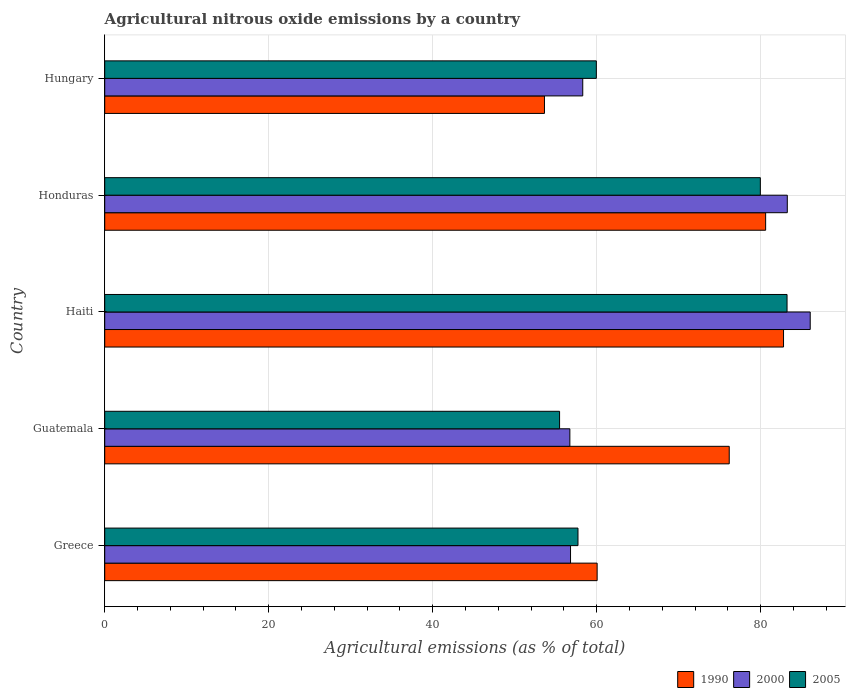How many groups of bars are there?
Provide a short and direct response. 5. Are the number of bars on each tick of the Y-axis equal?
Give a very brief answer. Yes. How many bars are there on the 2nd tick from the top?
Your answer should be very brief. 3. What is the label of the 2nd group of bars from the top?
Your answer should be compact. Honduras. What is the amount of agricultural nitrous oxide emitted in 1990 in Hungary?
Your answer should be very brief. 53.62. Across all countries, what is the maximum amount of agricultural nitrous oxide emitted in 1990?
Offer a terse response. 82.77. Across all countries, what is the minimum amount of agricultural nitrous oxide emitted in 2005?
Keep it short and to the point. 55.47. In which country was the amount of agricultural nitrous oxide emitted in 1990 maximum?
Your answer should be compact. Haiti. In which country was the amount of agricultural nitrous oxide emitted in 2005 minimum?
Provide a succinct answer. Guatemala. What is the total amount of agricultural nitrous oxide emitted in 2000 in the graph?
Give a very brief answer. 341.08. What is the difference between the amount of agricultural nitrous oxide emitted in 2005 in Guatemala and that in Hungary?
Ensure brevity in your answer.  -4.48. What is the difference between the amount of agricultural nitrous oxide emitted in 1990 in Greece and the amount of agricultural nitrous oxide emitted in 2005 in Hungary?
Offer a terse response. 0.1. What is the average amount of agricultural nitrous oxide emitted in 2000 per country?
Your answer should be compact. 68.22. What is the difference between the amount of agricultural nitrous oxide emitted in 2000 and amount of agricultural nitrous oxide emitted in 2005 in Honduras?
Keep it short and to the point. 3.29. What is the ratio of the amount of agricultural nitrous oxide emitted in 1990 in Haiti to that in Honduras?
Give a very brief answer. 1.03. What is the difference between the highest and the second highest amount of agricultural nitrous oxide emitted in 2005?
Make the answer very short. 3.26. What is the difference between the highest and the lowest amount of agricultural nitrous oxide emitted in 2000?
Offer a very short reply. 29.31. Is it the case that in every country, the sum of the amount of agricultural nitrous oxide emitted in 2000 and amount of agricultural nitrous oxide emitted in 2005 is greater than the amount of agricultural nitrous oxide emitted in 1990?
Offer a very short reply. Yes. Are all the bars in the graph horizontal?
Make the answer very short. Yes. What is the difference between two consecutive major ticks on the X-axis?
Keep it short and to the point. 20. What is the title of the graph?
Your answer should be very brief. Agricultural nitrous oxide emissions by a country. Does "2010" appear as one of the legend labels in the graph?
Offer a terse response. No. What is the label or title of the X-axis?
Your answer should be very brief. Agricultural emissions (as % of total). What is the label or title of the Y-axis?
Offer a terse response. Country. What is the Agricultural emissions (as % of total) of 1990 in Greece?
Your answer should be compact. 60.05. What is the Agricultural emissions (as % of total) in 2000 in Greece?
Offer a very short reply. 56.8. What is the Agricultural emissions (as % of total) in 2005 in Greece?
Your response must be concise. 57.71. What is the Agricultural emissions (as % of total) of 1990 in Guatemala?
Give a very brief answer. 76.15. What is the Agricultural emissions (as % of total) in 2000 in Guatemala?
Offer a very short reply. 56.72. What is the Agricultural emissions (as % of total) of 2005 in Guatemala?
Ensure brevity in your answer.  55.47. What is the Agricultural emissions (as % of total) in 1990 in Haiti?
Your answer should be compact. 82.77. What is the Agricultural emissions (as % of total) in 2000 in Haiti?
Your answer should be very brief. 86.03. What is the Agricultural emissions (as % of total) in 2005 in Haiti?
Offer a terse response. 83.2. What is the Agricultural emissions (as % of total) of 1990 in Honduras?
Give a very brief answer. 80.59. What is the Agricultural emissions (as % of total) of 2000 in Honduras?
Ensure brevity in your answer.  83.23. What is the Agricultural emissions (as % of total) in 2005 in Honduras?
Ensure brevity in your answer.  79.95. What is the Agricultural emissions (as % of total) of 1990 in Hungary?
Provide a short and direct response. 53.62. What is the Agricultural emissions (as % of total) of 2000 in Hungary?
Provide a short and direct response. 58.29. What is the Agricultural emissions (as % of total) of 2005 in Hungary?
Provide a short and direct response. 59.95. Across all countries, what is the maximum Agricultural emissions (as % of total) of 1990?
Provide a succinct answer. 82.77. Across all countries, what is the maximum Agricultural emissions (as % of total) in 2000?
Offer a terse response. 86.03. Across all countries, what is the maximum Agricultural emissions (as % of total) in 2005?
Provide a short and direct response. 83.2. Across all countries, what is the minimum Agricultural emissions (as % of total) in 1990?
Ensure brevity in your answer.  53.62. Across all countries, what is the minimum Agricultural emissions (as % of total) in 2000?
Ensure brevity in your answer.  56.72. Across all countries, what is the minimum Agricultural emissions (as % of total) of 2005?
Offer a terse response. 55.47. What is the total Agricultural emissions (as % of total) of 1990 in the graph?
Ensure brevity in your answer.  353.19. What is the total Agricultural emissions (as % of total) of 2000 in the graph?
Provide a short and direct response. 341.07. What is the total Agricultural emissions (as % of total) in 2005 in the graph?
Offer a terse response. 336.27. What is the difference between the Agricultural emissions (as % of total) of 1990 in Greece and that in Guatemala?
Your answer should be very brief. -16.11. What is the difference between the Agricultural emissions (as % of total) in 2000 in Greece and that in Guatemala?
Keep it short and to the point. 0.08. What is the difference between the Agricultural emissions (as % of total) in 2005 in Greece and that in Guatemala?
Keep it short and to the point. 2.24. What is the difference between the Agricultural emissions (as % of total) in 1990 in Greece and that in Haiti?
Provide a short and direct response. -22.73. What is the difference between the Agricultural emissions (as % of total) in 2000 in Greece and that in Haiti?
Your response must be concise. -29.23. What is the difference between the Agricultural emissions (as % of total) of 2005 in Greece and that in Haiti?
Your answer should be very brief. -25.49. What is the difference between the Agricultural emissions (as % of total) in 1990 in Greece and that in Honduras?
Your answer should be very brief. -20.55. What is the difference between the Agricultural emissions (as % of total) in 2000 in Greece and that in Honduras?
Your answer should be compact. -26.43. What is the difference between the Agricultural emissions (as % of total) of 2005 in Greece and that in Honduras?
Offer a very short reply. -22.24. What is the difference between the Agricultural emissions (as % of total) in 1990 in Greece and that in Hungary?
Your answer should be very brief. 6.42. What is the difference between the Agricultural emissions (as % of total) of 2000 in Greece and that in Hungary?
Offer a very short reply. -1.49. What is the difference between the Agricultural emissions (as % of total) in 2005 in Greece and that in Hungary?
Keep it short and to the point. -2.24. What is the difference between the Agricultural emissions (as % of total) of 1990 in Guatemala and that in Haiti?
Your answer should be compact. -6.62. What is the difference between the Agricultural emissions (as % of total) in 2000 in Guatemala and that in Haiti?
Offer a very short reply. -29.31. What is the difference between the Agricultural emissions (as % of total) of 2005 in Guatemala and that in Haiti?
Offer a terse response. -27.74. What is the difference between the Agricultural emissions (as % of total) of 1990 in Guatemala and that in Honduras?
Make the answer very short. -4.44. What is the difference between the Agricultural emissions (as % of total) of 2000 in Guatemala and that in Honduras?
Give a very brief answer. -26.52. What is the difference between the Agricultural emissions (as % of total) in 2005 in Guatemala and that in Honduras?
Make the answer very short. -24.48. What is the difference between the Agricultural emissions (as % of total) in 1990 in Guatemala and that in Hungary?
Your answer should be very brief. 22.53. What is the difference between the Agricultural emissions (as % of total) in 2000 in Guatemala and that in Hungary?
Ensure brevity in your answer.  -1.57. What is the difference between the Agricultural emissions (as % of total) of 2005 in Guatemala and that in Hungary?
Your answer should be very brief. -4.48. What is the difference between the Agricultural emissions (as % of total) of 1990 in Haiti and that in Honduras?
Your response must be concise. 2.18. What is the difference between the Agricultural emissions (as % of total) of 2000 in Haiti and that in Honduras?
Give a very brief answer. 2.79. What is the difference between the Agricultural emissions (as % of total) in 2005 in Haiti and that in Honduras?
Ensure brevity in your answer.  3.26. What is the difference between the Agricultural emissions (as % of total) of 1990 in Haiti and that in Hungary?
Ensure brevity in your answer.  29.15. What is the difference between the Agricultural emissions (as % of total) of 2000 in Haiti and that in Hungary?
Provide a succinct answer. 27.74. What is the difference between the Agricultural emissions (as % of total) of 2005 in Haiti and that in Hungary?
Your answer should be very brief. 23.25. What is the difference between the Agricultural emissions (as % of total) of 1990 in Honduras and that in Hungary?
Your response must be concise. 26.97. What is the difference between the Agricultural emissions (as % of total) of 2000 in Honduras and that in Hungary?
Provide a short and direct response. 24.94. What is the difference between the Agricultural emissions (as % of total) of 2005 in Honduras and that in Hungary?
Offer a very short reply. 20. What is the difference between the Agricultural emissions (as % of total) in 1990 in Greece and the Agricultural emissions (as % of total) in 2000 in Guatemala?
Your answer should be compact. 3.33. What is the difference between the Agricultural emissions (as % of total) in 1990 in Greece and the Agricultural emissions (as % of total) in 2005 in Guatemala?
Your answer should be very brief. 4.58. What is the difference between the Agricultural emissions (as % of total) in 2000 in Greece and the Agricultural emissions (as % of total) in 2005 in Guatemala?
Your answer should be compact. 1.34. What is the difference between the Agricultural emissions (as % of total) in 1990 in Greece and the Agricultural emissions (as % of total) in 2000 in Haiti?
Make the answer very short. -25.98. What is the difference between the Agricultural emissions (as % of total) in 1990 in Greece and the Agricultural emissions (as % of total) in 2005 in Haiti?
Keep it short and to the point. -23.16. What is the difference between the Agricultural emissions (as % of total) in 2000 in Greece and the Agricultural emissions (as % of total) in 2005 in Haiti?
Keep it short and to the point. -26.4. What is the difference between the Agricultural emissions (as % of total) of 1990 in Greece and the Agricultural emissions (as % of total) of 2000 in Honduras?
Offer a terse response. -23.19. What is the difference between the Agricultural emissions (as % of total) in 1990 in Greece and the Agricultural emissions (as % of total) in 2005 in Honduras?
Offer a terse response. -19.9. What is the difference between the Agricultural emissions (as % of total) in 2000 in Greece and the Agricultural emissions (as % of total) in 2005 in Honduras?
Provide a short and direct response. -23.15. What is the difference between the Agricultural emissions (as % of total) of 1990 in Greece and the Agricultural emissions (as % of total) of 2000 in Hungary?
Give a very brief answer. 1.76. What is the difference between the Agricultural emissions (as % of total) in 1990 in Greece and the Agricultural emissions (as % of total) in 2005 in Hungary?
Your response must be concise. 0.1. What is the difference between the Agricultural emissions (as % of total) in 2000 in Greece and the Agricultural emissions (as % of total) in 2005 in Hungary?
Offer a terse response. -3.15. What is the difference between the Agricultural emissions (as % of total) in 1990 in Guatemala and the Agricultural emissions (as % of total) in 2000 in Haiti?
Ensure brevity in your answer.  -9.88. What is the difference between the Agricultural emissions (as % of total) in 1990 in Guatemala and the Agricultural emissions (as % of total) in 2005 in Haiti?
Your response must be concise. -7.05. What is the difference between the Agricultural emissions (as % of total) of 2000 in Guatemala and the Agricultural emissions (as % of total) of 2005 in Haiti?
Provide a succinct answer. -26.48. What is the difference between the Agricultural emissions (as % of total) of 1990 in Guatemala and the Agricultural emissions (as % of total) of 2000 in Honduras?
Your answer should be very brief. -7.08. What is the difference between the Agricultural emissions (as % of total) of 1990 in Guatemala and the Agricultural emissions (as % of total) of 2005 in Honduras?
Provide a short and direct response. -3.79. What is the difference between the Agricultural emissions (as % of total) in 2000 in Guatemala and the Agricultural emissions (as % of total) in 2005 in Honduras?
Your response must be concise. -23.23. What is the difference between the Agricultural emissions (as % of total) of 1990 in Guatemala and the Agricultural emissions (as % of total) of 2000 in Hungary?
Give a very brief answer. 17.86. What is the difference between the Agricultural emissions (as % of total) of 1990 in Guatemala and the Agricultural emissions (as % of total) of 2005 in Hungary?
Keep it short and to the point. 16.2. What is the difference between the Agricultural emissions (as % of total) of 2000 in Guatemala and the Agricultural emissions (as % of total) of 2005 in Hungary?
Make the answer very short. -3.23. What is the difference between the Agricultural emissions (as % of total) of 1990 in Haiti and the Agricultural emissions (as % of total) of 2000 in Honduras?
Offer a very short reply. -0.46. What is the difference between the Agricultural emissions (as % of total) in 1990 in Haiti and the Agricultural emissions (as % of total) in 2005 in Honduras?
Offer a terse response. 2.83. What is the difference between the Agricultural emissions (as % of total) in 2000 in Haiti and the Agricultural emissions (as % of total) in 2005 in Honduras?
Your answer should be compact. 6.08. What is the difference between the Agricultural emissions (as % of total) in 1990 in Haiti and the Agricultural emissions (as % of total) in 2000 in Hungary?
Your response must be concise. 24.48. What is the difference between the Agricultural emissions (as % of total) of 1990 in Haiti and the Agricultural emissions (as % of total) of 2005 in Hungary?
Make the answer very short. 22.83. What is the difference between the Agricultural emissions (as % of total) in 2000 in Haiti and the Agricultural emissions (as % of total) in 2005 in Hungary?
Make the answer very short. 26.08. What is the difference between the Agricultural emissions (as % of total) of 1990 in Honduras and the Agricultural emissions (as % of total) of 2000 in Hungary?
Provide a short and direct response. 22.3. What is the difference between the Agricultural emissions (as % of total) in 1990 in Honduras and the Agricultural emissions (as % of total) in 2005 in Hungary?
Ensure brevity in your answer.  20.64. What is the difference between the Agricultural emissions (as % of total) in 2000 in Honduras and the Agricultural emissions (as % of total) in 2005 in Hungary?
Offer a terse response. 23.29. What is the average Agricultural emissions (as % of total) in 1990 per country?
Offer a terse response. 70.64. What is the average Agricultural emissions (as % of total) of 2000 per country?
Your answer should be very brief. 68.22. What is the average Agricultural emissions (as % of total) in 2005 per country?
Offer a very short reply. 67.25. What is the difference between the Agricultural emissions (as % of total) of 1990 and Agricultural emissions (as % of total) of 2000 in Greece?
Make the answer very short. 3.24. What is the difference between the Agricultural emissions (as % of total) in 1990 and Agricultural emissions (as % of total) in 2005 in Greece?
Provide a succinct answer. 2.34. What is the difference between the Agricultural emissions (as % of total) of 2000 and Agricultural emissions (as % of total) of 2005 in Greece?
Provide a succinct answer. -0.91. What is the difference between the Agricultural emissions (as % of total) of 1990 and Agricultural emissions (as % of total) of 2000 in Guatemala?
Give a very brief answer. 19.43. What is the difference between the Agricultural emissions (as % of total) in 1990 and Agricultural emissions (as % of total) in 2005 in Guatemala?
Give a very brief answer. 20.69. What is the difference between the Agricultural emissions (as % of total) of 2000 and Agricultural emissions (as % of total) of 2005 in Guatemala?
Your answer should be very brief. 1.25. What is the difference between the Agricultural emissions (as % of total) of 1990 and Agricultural emissions (as % of total) of 2000 in Haiti?
Your answer should be very brief. -3.25. What is the difference between the Agricultural emissions (as % of total) in 1990 and Agricultural emissions (as % of total) in 2005 in Haiti?
Ensure brevity in your answer.  -0.43. What is the difference between the Agricultural emissions (as % of total) of 2000 and Agricultural emissions (as % of total) of 2005 in Haiti?
Ensure brevity in your answer.  2.83. What is the difference between the Agricultural emissions (as % of total) of 1990 and Agricultural emissions (as % of total) of 2000 in Honduras?
Your answer should be very brief. -2.64. What is the difference between the Agricultural emissions (as % of total) in 1990 and Agricultural emissions (as % of total) in 2005 in Honduras?
Provide a short and direct response. 0.65. What is the difference between the Agricultural emissions (as % of total) of 2000 and Agricultural emissions (as % of total) of 2005 in Honduras?
Offer a terse response. 3.29. What is the difference between the Agricultural emissions (as % of total) of 1990 and Agricultural emissions (as % of total) of 2000 in Hungary?
Your answer should be compact. -4.67. What is the difference between the Agricultural emissions (as % of total) of 1990 and Agricultural emissions (as % of total) of 2005 in Hungary?
Give a very brief answer. -6.33. What is the difference between the Agricultural emissions (as % of total) of 2000 and Agricultural emissions (as % of total) of 2005 in Hungary?
Your answer should be very brief. -1.66. What is the ratio of the Agricultural emissions (as % of total) in 1990 in Greece to that in Guatemala?
Offer a terse response. 0.79. What is the ratio of the Agricultural emissions (as % of total) of 2000 in Greece to that in Guatemala?
Offer a very short reply. 1. What is the ratio of the Agricultural emissions (as % of total) of 2005 in Greece to that in Guatemala?
Give a very brief answer. 1.04. What is the ratio of the Agricultural emissions (as % of total) of 1990 in Greece to that in Haiti?
Keep it short and to the point. 0.73. What is the ratio of the Agricultural emissions (as % of total) in 2000 in Greece to that in Haiti?
Make the answer very short. 0.66. What is the ratio of the Agricultural emissions (as % of total) in 2005 in Greece to that in Haiti?
Your response must be concise. 0.69. What is the ratio of the Agricultural emissions (as % of total) of 1990 in Greece to that in Honduras?
Your response must be concise. 0.74. What is the ratio of the Agricultural emissions (as % of total) in 2000 in Greece to that in Honduras?
Your response must be concise. 0.68. What is the ratio of the Agricultural emissions (as % of total) of 2005 in Greece to that in Honduras?
Keep it short and to the point. 0.72. What is the ratio of the Agricultural emissions (as % of total) in 1990 in Greece to that in Hungary?
Give a very brief answer. 1.12. What is the ratio of the Agricultural emissions (as % of total) in 2000 in Greece to that in Hungary?
Provide a succinct answer. 0.97. What is the ratio of the Agricultural emissions (as % of total) in 2005 in Greece to that in Hungary?
Your answer should be very brief. 0.96. What is the ratio of the Agricultural emissions (as % of total) of 1990 in Guatemala to that in Haiti?
Keep it short and to the point. 0.92. What is the ratio of the Agricultural emissions (as % of total) of 2000 in Guatemala to that in Haiti?
Your response must be concise. 0.66. What is the ratio of the Agricultural emissions (as % of total) of 2005 in Guatemala to that in Haiti?
Offer a very short reply. 0.67. What is the ratio of the Agricultural emissions (as % of total) of 1990 in Guatemala to that in Honduras?
Make the answer very short. 0.94. What is the ratio of the Agricultural emissions (as % of total) of 2000 in Guatemala to that in Honduras?
Your answer should be compact. 0.68. What is the ratio of the Agricultural emissions (as % of total) of 2005 in Guatemala to that in Honduras?
Offer a very short reply. 0.69. What is the ratio of the Agricultural emissions (as % of total) of 1990 in Guatemala to that in Hungary?
Offer a terse response. 1.42. What is the ratio of the Agricultural emissions (as % of total) in 2005 in Guatemala to that in Hungary?
Offer a terse response. 0.93. What is the ratio of the Agricultural emissions (as % of total) in 1990 in Haiti to that in Honduras?
Keep it short and to the point. 1.03. What is the ratio of the Agricultural emissions (as % of total) of 2000 in Haiti to that in Honduras?
Make the answer very short. 1.03. What is the ratio of the Agricultural emissions (as % of total) of 2005 in Haiti to that in Honduras?
Ensure brevity in your answer.  1.04. What is the ratio of the Agricultural emissions (as % of total) in 1990 in Haiti to that in Hungary?
Your answer should be very brief. 1.54. What is the ratio of the Agricultural emissions (as % of total) in 2000 in Haiti to that in Hungary?
Make the answer very short. 1.48. What is the ratio of the Agricultural emissions (as % of total) of 2005 in Haiti to that in Hungary?
Your response must be concise. 1.39. What is the ratio of the Agricultural emissions (as % of total) of 1990 in Honduras to that in Hungary?
Keep it short and to the point. 1.5. What is the ratio of the Agricultural emissions (as % of total) of 2000 in Honduras to that in Hungary?
Your answer should be very brief. 1.43. What is the ratio of the Agricultural emissions (as % of total) of 2005 in Honduras to that in Hungary?
Your answer should be compact. 1.33. What is the difference between the highest and the second highest Agricultural emissions (as % of total) of 1990?
Make the answer very short. 2.18. What is the difference between the highest and the second highest Agricultural emissions (as % of total) of 2000?
Keep it short and to the point. 2.79. What is the difference between the highest and the second highest Agricultural emissions (as % of total) of 2005?
Your answer should be compact. 3.26. What is the difference between the highest and the lowest Agricultural emissions (as % of total) of 1990?
Your answer should be compact. 29.15. What is the difference between the highest and the lowest Agricultural emissions (as % of total) of 2000?
Keep it short and to the point. 29.31. What is the difference between the highest and the lowest Agricultural emissions (as % of total) in 2005?
Ensure brevity in your answer.  27.74. 